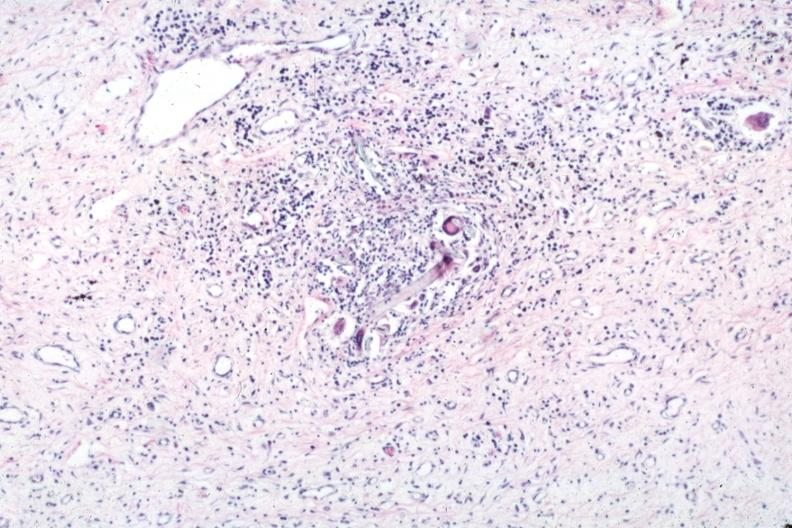s suture granuloma present?
Answer the question using a single word or phrase. Yes 